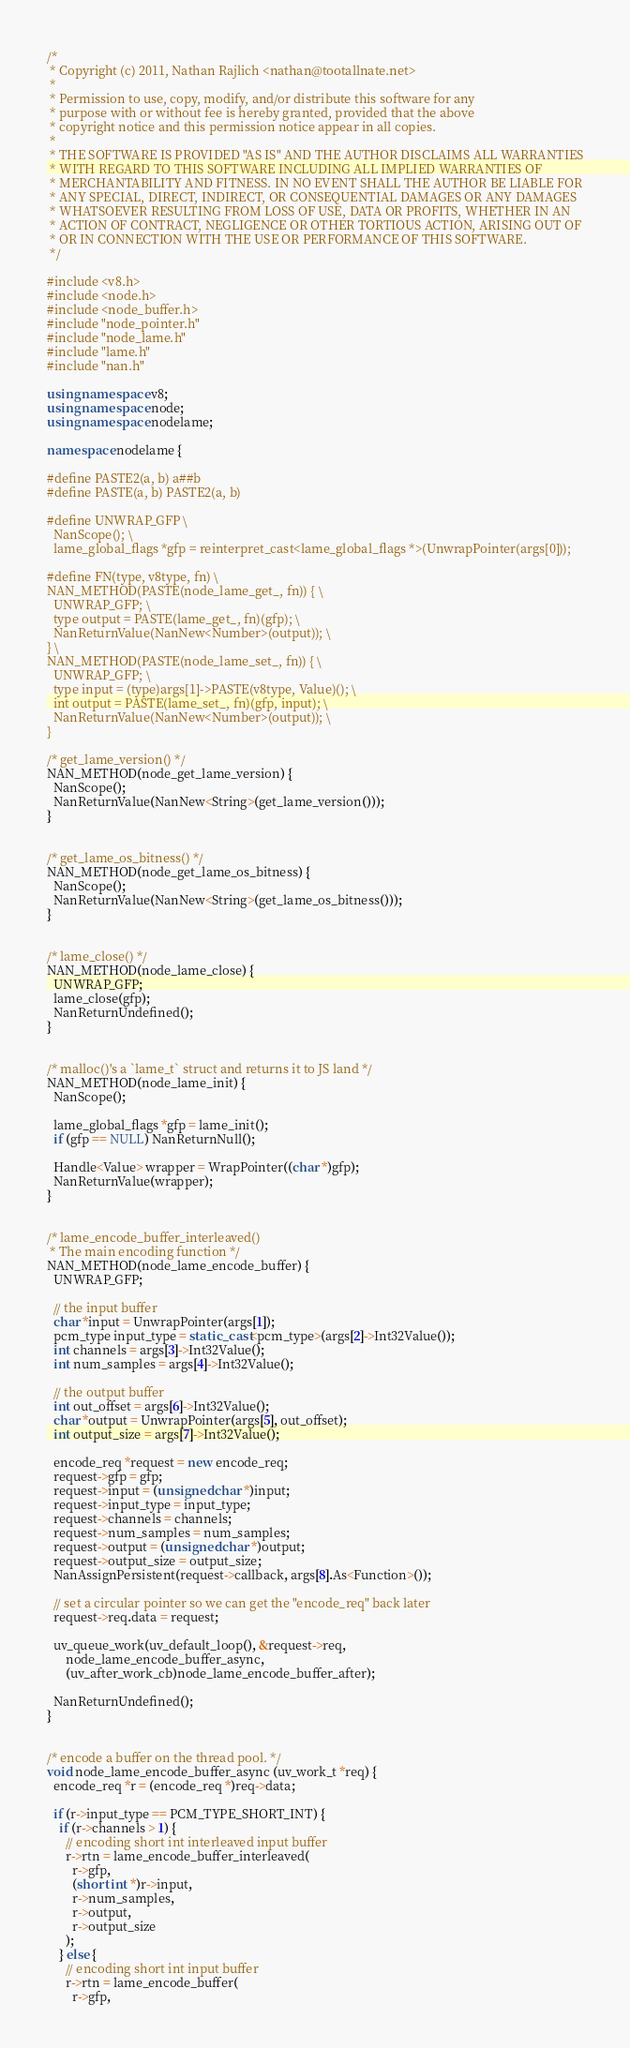<code> <loc_0><loc_0><loc_500><loc_500><_C++_>/*
 * Copyright (c) 2011, Nathan Rajlich <nathan@tootallnate.net>
 *
 * Permission to use, copy, modify, and/or distribute this software for any
 * purpose with or without fee is hereby granted, provided that the above
 * copyright notice and this permission notice appear in all copies.
 *
 * THE SOFTWARE IS PROVIDED "AS IS" AND THE AUTHOR DISCLAIMS ALL WARRANTIES
 * WITH REGARD TO THIS SOFTWARE INCLUDING ALL IMPLIED WARRANTIES OF
 * MERCHANTABILITY AND FITNESS. IN NO EVENT SHALL THE AUTHOR BE LIABLE FOR
 * ANY SPECIAL, DIRECT, INDIRECT, OR CONSEQUENTIAL DAMAGES OR ANY DAMAGES
 * WHATSOEVER RESULTING FROM LOSS OF USE, DATA OR PROFITS, WHETHER IN AN
 * ACTION OF CONTRACT, NEGLIGENCE OR OTHER TORTIOUS ACTION, ARISING OUT OF
 * OR IN CONNECTION WITH THE USE OR PERFORMANCE OF THIS SOFTWARE.
 */

#include <v8.h>
#include <node.h>
#include <node_buffer.h>
#include "node_pointer.h"
#include "node_lame.h"
#include "lame.h"
#include "nan.h"

using namespace v8;
using namespace node;
using namespace nodelame;

namespace nodelame {

#define PASTE2(a, b) a##b
#define PASTE(a, b) PASTE2(a, b)

#define UNWRAP_GFP \
  NanScope(); \
  lame_global_flags *gfp = reinterpret_cast<lame_global_flags *>(UnwrapPointer(args[0]));

#define FN(type, v8type, fn) \
NAN_METHOD(PASTE(node_lame_get_, fn)) { \
  UNWRAP_GFP; \
  type output = PASTE(lame_get_, fn)(gfp); \
  NanReturnValue(NanNew<Number>(output)); \
} \
NAN_METHOD(PASTE(node_lame_set_, fn)) { \
  UNWRAP_GFP; \
  type input = (type)args[1]->PASTE(v8type, Value)(); \
  int output = PASTE(lame_set_, fn)(gfp, input); \
  NanReturnValue(NanNew<Number>(output)); \
}

/* get_lame_version() */
NAN_METHOD(node_get_lame_version) {
  NanScope();
  NanReturnValue(NanNew<String>(get_lame_version()));
}


/* get_lame_os_bitness() */
NAN_METHOD(node_get_lame_os_bitness) {
  NanScope();
  NanReturnValue(NanNew<String>(get_lame_os_bitness()));
}


/* lame_close() */
NAN_METHOD(node_lame_close) {
  UNWRAP_GFP;
  lame_close(gfp);
  NanReturnUndefined();
}


/* malloc()'s a `lame_t` struct and returns it to JS land */
NAN_METHOD(node_lame_init) {
  NanScope();

  lame_global_flags *gfp = lame_init();
  if (gfp == NULL) NanReturnNull();

  Handle<Value> wrapper = WrapPointer((char *)gfp);
  NanReturnValue(wrapper);
}


/* lame_encode_buffer_interleaved()
 * The main encoding function */
NAN_METHOD(node_lame_encode_buffer) {
  UNWRAP_GFP;

  // the input buffer
  char *input = UnwrapPointer(args[1]);
  pcm_type input_type = static_cast<pcm_type>(args[2]->Int32Value());
  int channels = args[3]->Int32Value();
  int num_samples = args[4]->Int32Value();

  // the output buffer
  int out_offset = args[6]->Int32Value();
  char *output = UnwrapPointer(args[5], out_offset);
  int output_size = args[7]->Int32Value();

  encode_req *request = new encode_req;
  request->gfp = gfp;
  request->input = (unsigned char *)input;
  request->input_type = input_type;
  request->channels = channels;
  request->num_samples = num_samples;
  request->output = (unsigned char *)output;
  request->output_size = output_size;
  NanAssignPersistent(request->callback, args[8].As<Function>());

  // set a circular pointer so we can get the "encode_req" back later
  request->req.data = request;

  uv_queue_work(uv_default_loop(), &request->req,
      node_lame_encode_buffer_async,
      (uv_after_work_cb)node_lame_encode_buffer_after);

  NanReturnUndefined();
}


/* encode a buffer on the thread pool. */
void node_lame_encode_buffer_async (uv_work_t *req) {
  encode_req *r = (encode_req *)req->data;

  if (r->input_type == PCM_TYPE_SHORT_INT) {
    if (r->channels > 1) {
      // encoding short int interleaved input buffer
      r->rtn = lame_encode_buffer_interleaved(
        r->gfp,
        (short int *)r->input,
        r->num_samples,
        r->output,
        r->output_size
      );
    } else {
      // encoding short int input buffer
      r->rtn = lame_encode_buffer(
        r->gfp,</code> 